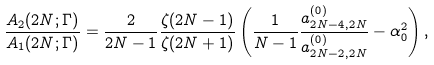<formula> <loc_0><loc_0><loc_500><loc_500>\frac { A _ { 2 } ( 2 N ; \Gamma ) } { A _ { 1 } ( 2 N ; \Gamma ) } = \frac { 2 } { 2 N - 1 } \frac { \zeta ( 2 N - 1 ) } { \zeta ( 2 N + 1 ) } \left ( \frac { 1 } { N - 1 } \frac { a _ { 2 N - 4 , 2 N } ^ { ( 0 ) } } { a _ { 2 N - 2 , 2 N } ^ { ( 0 ) } } - \alpha _ { 0 } ^ { 2 } \right ) ,</formula> 